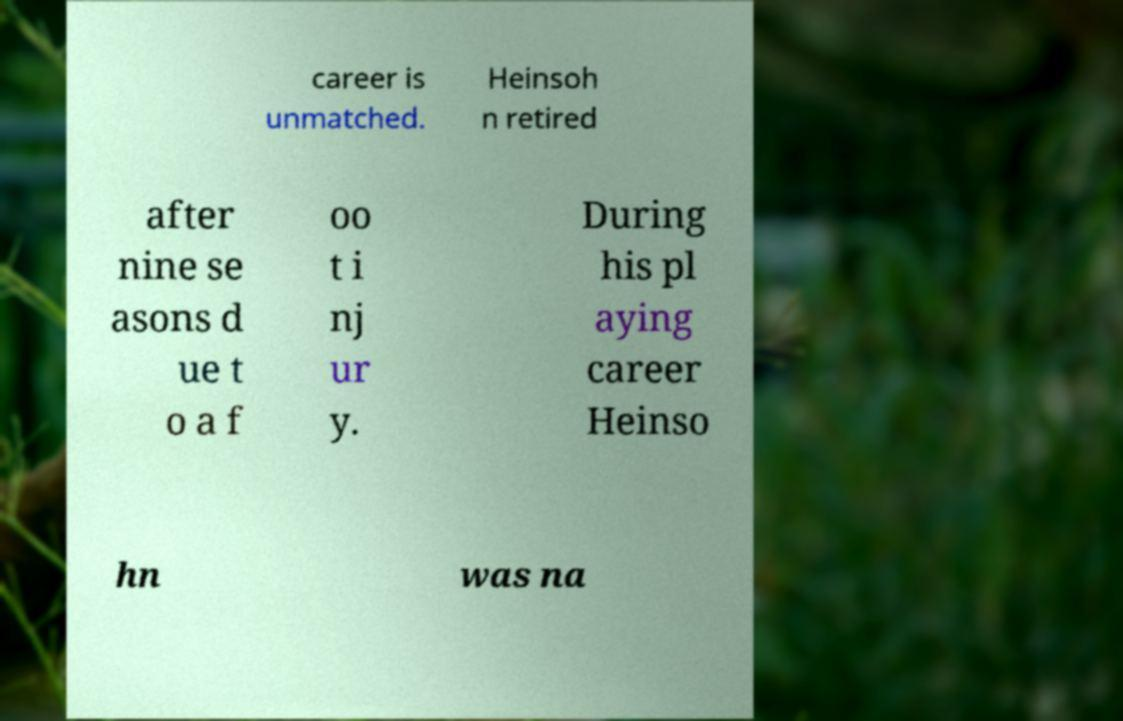Please read and relay the text visible in this image. What does it say? career is unmatched. Heinsoh n retired after nine se asons d ue t o a f oo t i nj ur y. During his pl aying career Heinso hn was na 